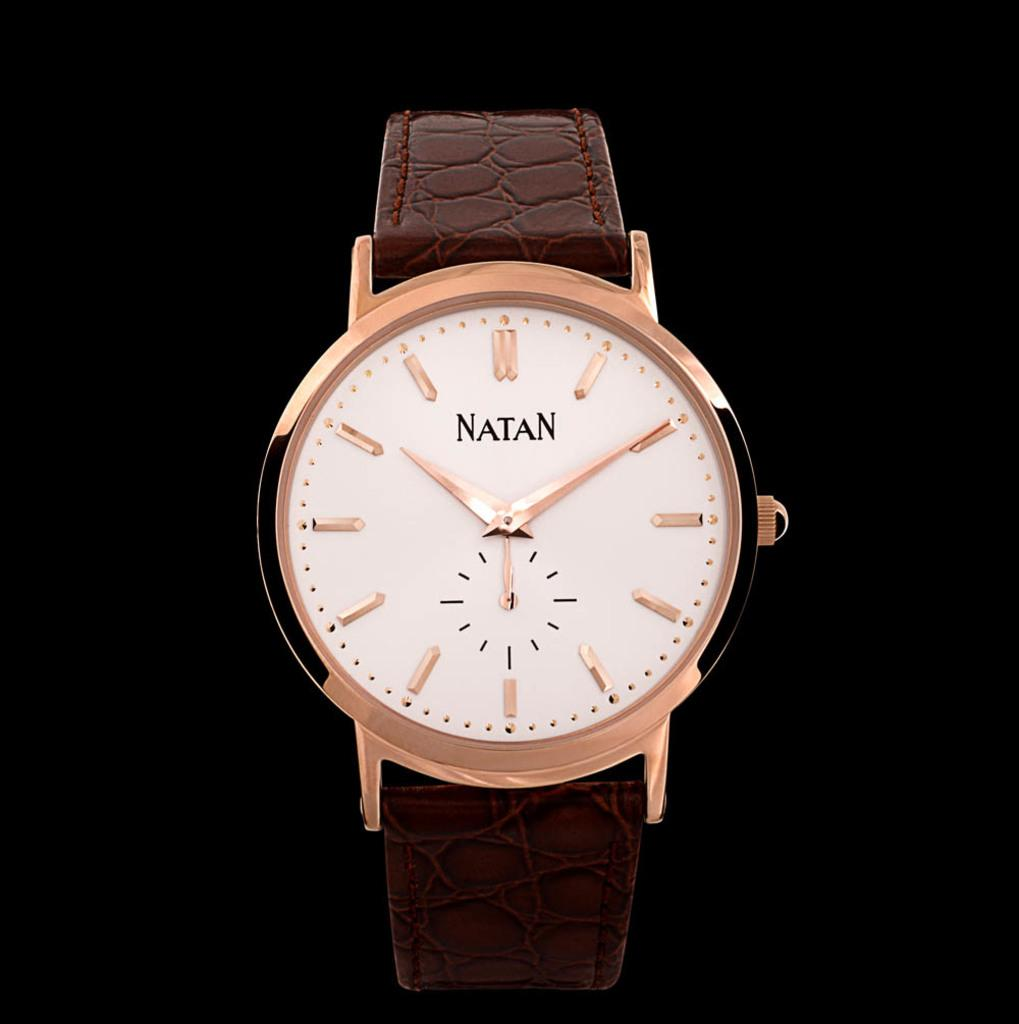<image>
Describe the image concisely. A Natan brand watch with a leather strap is on display. 